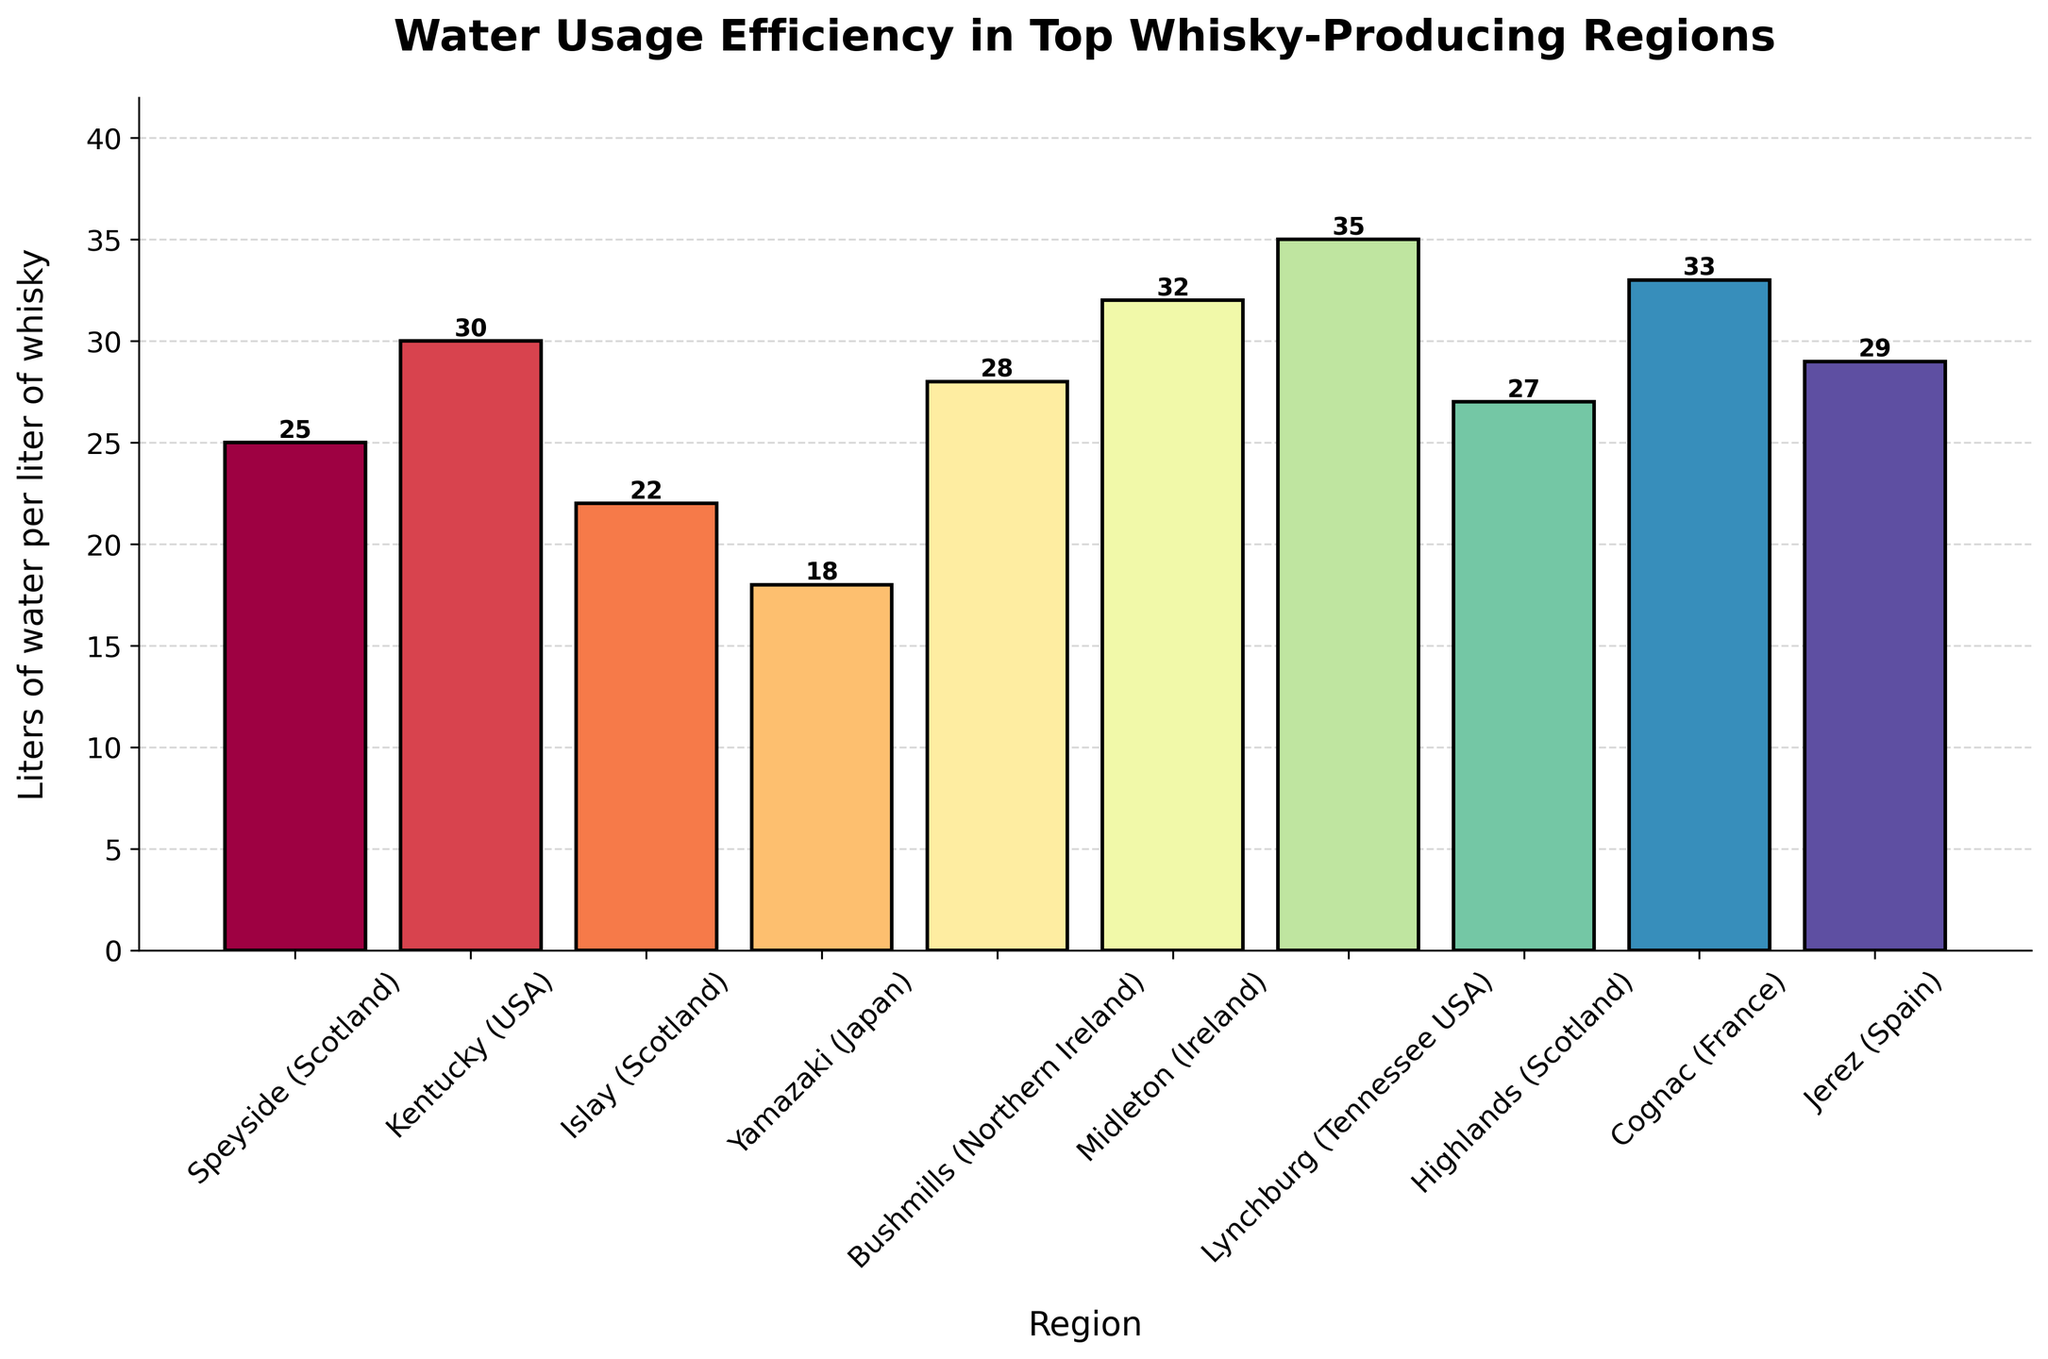Which region has the highest water usage efficiency? The bar representing Yamazaki (Japan) is the shortest among all the regions, indicating it has the lowest water usage. The label at the top of the bar shows 18 liters of water per liter of whisky.
Answer: Yamazaki (Japan) Which region has the lowest water usage efficiency? The bar for Lynchburg (Tennessee USA) is the tallest among all regions, indicating it has the highest water usage. The value at the top of the bar shows 35 liters of water per liter of whisky.
Answer: Lynchburg (Tennessee USA) How does the water usage efficiency in Kentucky (USA) compare to that in Islay (Scotland)? The bar for Kentucky shows a water usage of 30 liters, while the bar for Islay shows a lower figure of 22 liters. Comparing the two values, Kentucky uses more water per liter of whisky than Islay.
Answer: Kentucky uses more water than Islay What is the average water usage efficiency across all listed regions? To find the average, sum the water usage values (25 + 30 + 22 + 18 + 28 + 32 + 35 + 27 + 33 + 29) which equals 279 liters. Since there are 10 regions, the average is 279/10.
Answer: 27.9 liters per liter of whisky Which regions have a water usage efficiency less than 25 liters of water per liter of whisky? Looking at the bars, the regions with less than 25 liters are Yamazaki (18 liters) and Islay (22 liters).
Answer: Yamazaki and Islay What is the difference in water usage efficiency between the least efficient and most efficient regions? The least efficient region is Lynchburg with 35 liters, and the most efficient is Yamazaki with 18 liters. The difference is 35 - 18.
Answer: 17 liters per liter of whisky Rank the regions from most to least efficient in terms of water usage. By looking at the bar heights and values from the smallest to the largest: Yamazaki (18), Islay (22), Speyside (25), Highlands (27), Bushmills (28), Jerez (29), Kentucky (30), Midleton (32), Cognac (33), Lynchburg (35).
Answer: Yamazaki, Islay, Speyside, Highlands, Bushmills, Jerez, Kentucky, Midleton, Cognac, Lynchburg What is the combined water usage efficiency for all the regions in Scotland? The regions in Scotland are Speyside (25), Islay (22), and Highlands (27). Their combined efficiency is 25 + 22 + 27.
Answer: 74 liters per liter of whisky Is the water usage efficiency of Jerez (Spain) closer to that of Bushmills (Northern Ireland) or Cognac (France)? Jerez has 29 liters, Bushmills has 28 liters, and Cognac has 33 liters. The difference between Jerez and Bushmills is 1 liter, and between Jerez and Cognac is 4 liters. Jerez is closer to Bushmills.
Answer: Bushmills What is the median water usage efficiency of all regions? To find the median, first order the values: 18, 22, 25, 27, 28, 29, 30, 32, 33, 35. With 10 values, the median is the average of the 5th and 6th values. (28 + 29) / 2.
Answer: 28.5 liters per liter of whisky 